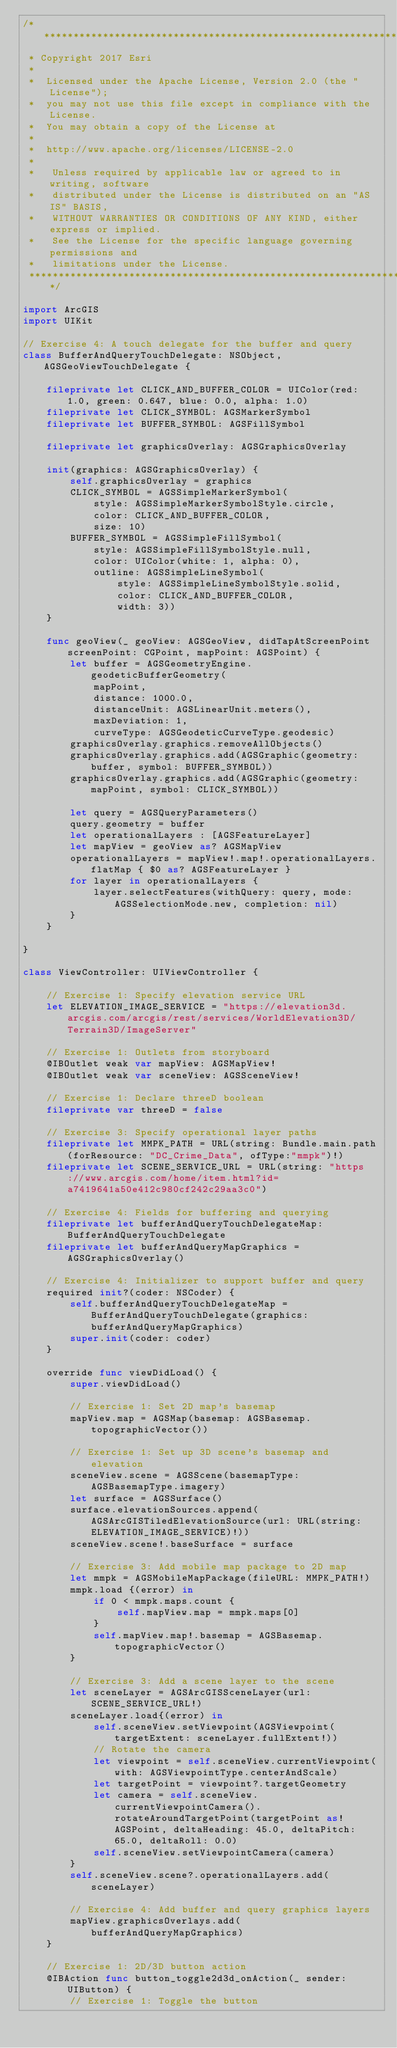Convert code to text. <code><loc_0><loc_0><loc_500><loc_500><_Swift_>/*******************************************************************************
 * Copyright 2017 Esri
 *
 *  Licensed under the Apache License, Version 2.0 (the "License");
 *  you may not use this file except in compliance with the License.
 *  You may obtain a copy of the License at
 *
 *  http://www.apache.org/licenses/LICENSE-2.0
 *
 *   Unless required by applicable law or agreed to in writing, software
 *   distributed under the License is distributed on an "AS IS" BASIS,
 *   WITHOUT WARRANTIES OR CONDITIONS OF ANY KIND, either express or implied.
 *   See the License for the specific language governing permissions and
 *   limitations under the License.
 ******************************************************************************/

import ArcGIS
import UIKit

// Exercise 4: A touch delegate for the buffer and query
class BufferAndQueryTouchDelegate: NSObject, AGSGeoViewTouchDelegate {
    
    fileprivate let CLICK_AND_BUFFER_COLOR = UIColor(red: 1.0, green: 0.647, blue: 0.0, alpha: 1.0)
    fileprivate let CLICK_SYMBOL: AGSMarkerSymbol
    fileprivate let BUFFER_SYMBOL: AGSFillSymbol
    
    fileprivate let graphicsOverlay: AGSGraphicsOverlay
    
    init(graphics: AGSGraphicsOverlay) {
        self.graphicsOverlay = graphics
        CLICK_SYMBOL = AGSSimpleMarkerSymbol(
            style: AGSSimpleMarkerSymbolStyle.circle,
            color: CLICK_AND_BUFFER_COLOR,
            size: 10)
        BUFFER_SYMBOL = AGSSimpleFillSymbol(
            style: AGSSimpleFillSymbolStyle.null,
            color: UIColor(white: 1, alpha: 0),
            outline: AGSSimpleLineSymbol(
                style: AGSSimpleLineSymbolStyle.solid,
                color: CLICK_AND_BUFFER_COLOR,
                width: 3))
    }
    
    func geoView(_ geoView: AGSGeoView, didTapAtScreenPoint screenPoint: CGPoint, mapPoint: AGSPoint) {
        let buffer = AGSGeometryEngine.geodeticBufferGeometry(
            mapPoint,
            distance: 1000.0,
            distanceUnit: AGSLinearUnit.meters(),
            maxDeviation: 1,
            curveType: AGSGeodeticCurveType.geodesic)
        graphicsOverlay.graphics.removeAllObjects()
        graphicsOverlay.graphics.add(AGSGraphic(geometry: buffer, symbol: BUFFER_SYMBOL))
        graphicsOverlay.graphics.add(AGSGraphic(geometry: mapPoint, symbol: CLICK_SYMBOL))
        
        let query = AGSQueryParameters()
        query.geometry = buffer
        let operationalLayers : [AGSFeatureLayer]
        let mapView = geoView as? AGSMapView
        operationalLayers = mapView!.map!.operationalLayers.flatMap { $0 as? AGSFeatureLayer }
        for layer in operationalLayers {
            layer.selectFeatures(withQuery: query, mode: AGSSelectionMode.new, completion: nil)
        }
    }
    
}

class ViewController: UIViewController {
    
    // Exercise 1: Specify elevation service URL
    let ELEVATION_IMAGE_SERVICE = "https://elevation3d.arcgis.com/arcgis/rest/services/WorldElevation3D/Terrain3D/ImageServer"

    // Exercise 1: Outlets from storyboard
    @IBOutlet weak var mapView: AGSMapView!
    @IBOutlet weak var sceneView: AGSSceneView!
    
    // Exercise 1: Declare threeD boolean
    fileprivate var threeD = false
    
    // Exercise 3: Specify operational layer paths
    fileprivate let MMPK_PATH = URL(string: Bundle.main.path(forResource: "DC_Crime_Data", ofType:"mmpk")!)
    fileprivate let SCENE_SERVICE_URL = URL(string: "https://www.arcgis.com/home/item.html?id=a7419641a50e412c980cf242c29aa3c0")
    
    // Exercise 4: Fields for buffering and querying
    fileprivate let bufferAndQueryTouchDelegateMap: BufferAndQueryTouchDelegate
    fileprivate let bufferAndQueryMapGraphics = AGSGraphicsOverlay()
    
    // Exercise 4: Initializer to support buffer and query
    required init?(coder: NSCoder) {
        self.bufferAndQueryTouchDelegateMap = BufferAndQueryTouchDelegate(graphics: bufferAndQueryMapGraphics)
        super.init(coder: coder)
    }

    override func viewDidLoad() {
        super.viewDidLoad()
        
        // Exercise 1: Set 2D map's basemap
        mapView.map = AGSMap(basemap: AGSBasemap.topographicVector())
        
        // Exercise 1: Set up 3D scene's basemap and elevation
        sceneView.scene = AGSScene(basemapType: AGSBasemapType.imagery)
        let surface = AGSSurface()
        surface.elevationSources.append(AGSArcGISTiledElevationSource(url: URL(string: ELEVATION_IMAGE_SERVICE)!))
        sceneView.scene!.baseSurface = surface
        
        // Exercise 3: Add mobile map package to 2D map
        let mmpk = AGSMobileMapPackage(fileURL: MMPK_PATH!)
        mmpk.load {(error) in
            if 0 < mmpk.maps.count {
                self.mapView.map = mmpk.maps[0]
            }
            self.mapView.map!.basemap = AGSBasemap.topographicVector()
        }
        
        // Exercise 3: Add a scene layer to the scene
        let sceneLayer = AGSArcGISSceneLayer(url: SCENE_SERVICE_URL!)
        sceneLayer.load{(error) in
            self.sceneView.setViewpoint(AGSViewpoint(targetExtent: sceneLayer.fullExtent!))
            // Rotate the camera
            let viewpoint = self.sceneView.currentViewpoint(with: AGSViewpointType.centerAndScale)
            let targetPoint = viewpoint?.targetGeometry
            let camera = self.sceneView.currentViewpointCamera().rotateAroundTargetPoint(targetPoint as! AGSPoint, deltaHeading: 45.0, deltaPitch: 65.0, deltaRoll: 0.0)
            self.sceneView.setViewpointCamera(camera)
        }
        self.sceneView.scene?.operationalLayers.add(sceneLayer)
        
        // Exercise 4: Add buffer and query graphics layers
        mapView.graphicsOverlays.add(bufferAndQueryMapGraphics)
    }
    
    // Exercise 1: 2D/3D button action
    @IBAction func button_toggle2d3d_onAction(_ sender: UIButton) {
        // Exercise 1: Toggle the button</code> 